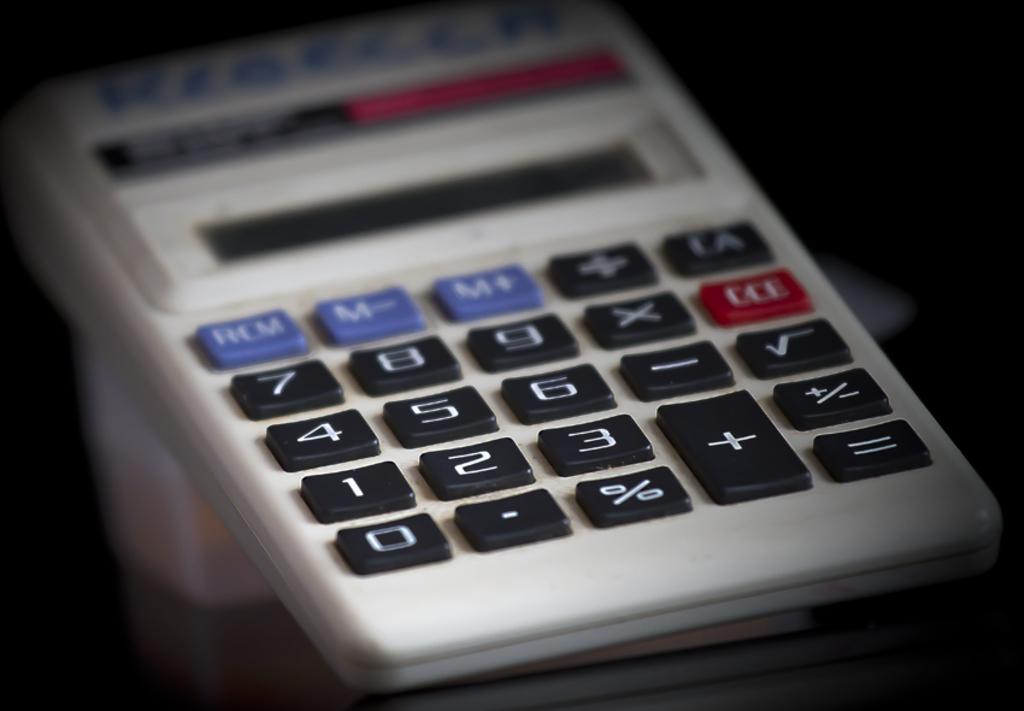<image>
Provide a brief description of the given image. White calculator with a blue button that says RCM. 